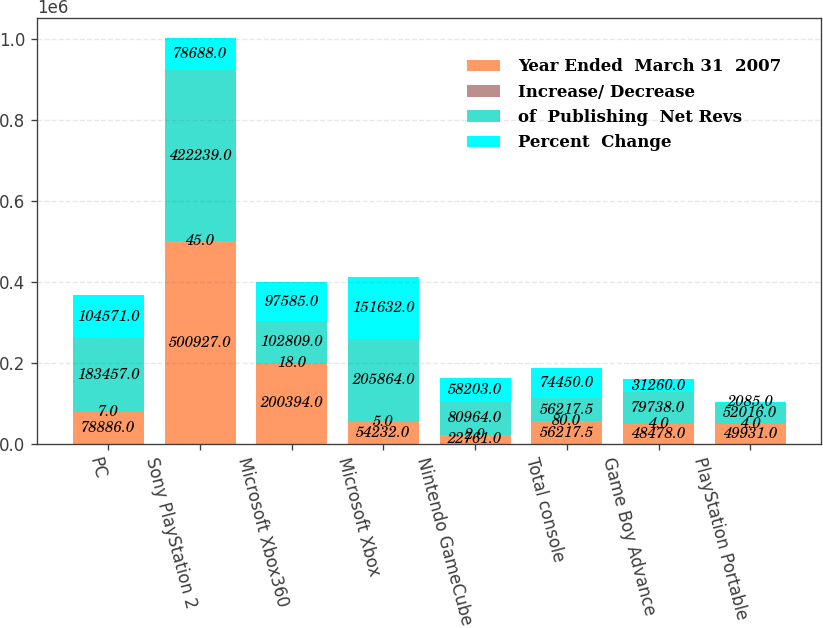Convert chart. <chart><loc_0><loc_0><loc_500><loc_500><stacked_bar_chart><ecel><fcel>PC<fcel>Sony PlayStation 2<fcel>Microsoft Xbox360<fcel>Microsoft Xbox<fcel>Nintendo GameCube<fcel>Total console<fcel>Game Boy Advance<fcel>PlayStation Portable<nl><fcel>Year Ended  March 31  2007<fcel>78886<fcel>500927<fcel>200394<fcel>54232<fcel>22761<fcel>56217.5<fcel>48478<fcel>49931<nl><fcel>Increase/ Decrease<fcel>7<fcel>45<fcel>18<fcel>5<fcel>2<fcel>80<fcel>4<fcel>4<nl><fcel>of  Publishing  Net Revs<fcel>183457<fcel>422239<fcel>102809<fcel>205864<fcel>80964<fcel>56217.5<fcel>79738<fcel>52016<nl><fcel>Percent  Change<fcel>104571<fcel>78688<fcel>97585<fcel>151632<fcel>58203<fcel>74450<fcel>31260<fcel>2085<nl></chart> 